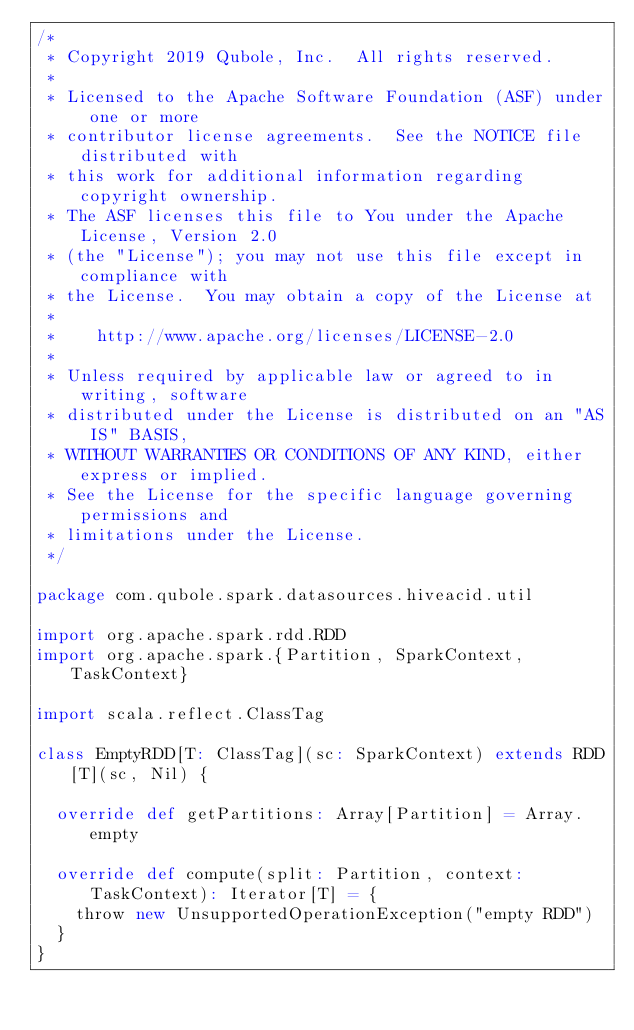Convert code to text. <code><loc_0><loc_0><loc_500><loc_500><_Scala_>/*
 * Copyright 2019 Qubole, Inc.  All rights reserved.
 *
 * Licensed to the Apache Software Foundation (ASF) under one or more
 * contributor license agreements.  See the NOTICE file distributed with
 * this work for additional information regarding copyright ownership.
 * The ASF licenses this file to You under the Apache License, Version 2.0
 * (the "License"); you may not use this file except in compliance with
 * the License.  You may obtain a copy of the License at
 *
 *    http://www.apache.org/licenses/LICENSE-2.0
 *
 * Unless required by applicable law or agreed to in writing, software
 * distributed under the License is distributed on an "AS IS" BASIS,
 * WITHOUT WARRANTIES OR CONDITIONS OF ANY KIND, either express or implied.
 * See the License for the specific language governing permissions and
 * limitations under the License.
 */

package com.qubole.spark.datasources.hiveacid.util

import org.apache.spark.rdd.RDD
import org.apache.spark.{Partition, SparkContext, TaskContext}

import scala.reflect.ClassTag

class EmptyRDD[T: ClassTag](sc: SparkContext) extends RDD[T](sc, Nil) {

  override def getPartitions: Array[Partition] = Array.empty

  override def compute(split: Partition, context: TaskContext): Iterator[T] = {
    throw new UnsupportedOperationException("empty RDD")
  }
}
</code> 